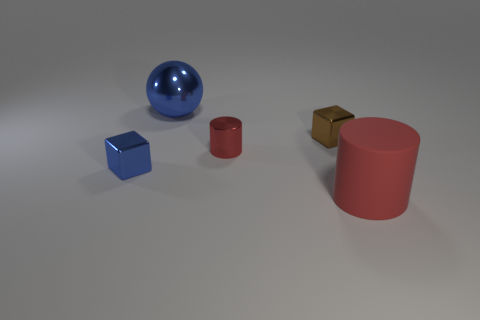Is there any other thing that is the same shape as the big red object?
Provide a short and direct response. Yes. Are there fewer blue metallic balls than purple matte cubes?
Make the answer very short. No. What is the object that is on the right side of the metallic cylinder and behind the tiny blue cube made of?
Keep it short and to the point. Metal. There is a blue shiny object that is in front of the brown metallic object; are there any blue shiny spheres that are to the left of it?
Give a very brief answer. No. What number of objects are either cyan things or blocks?
Make the answer very short. 2. There is a thing that is both on the right side of the tiny red cylinder and behind the rubber object; what is its shape?
Your answer should be compact. Cube. Is the red cylinder that is in front of the small blue block made of the same material as the big blue ball?
Offer a terse response. No. What number of things are blue cubes or tiny blue metal cubes in front of the blue metallic sphere?
Your answer should be very brief. 1. What is the color of the large object that is made of the same material as the small red cylinder?
Keep it short and to the point. Blue. How many cylinders are made of the same material as the sphere?
Your answer should be compact. 1. 